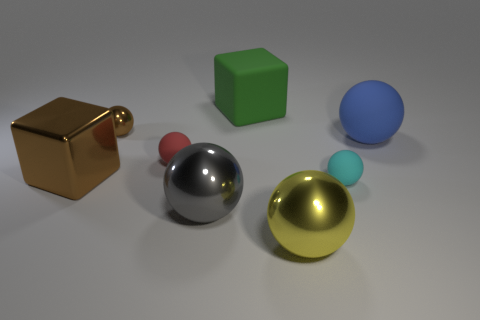Subtract all gray spheres. How many spheres are left? 5 Subtract all small brown metallic spheres. How many spheres are left? 5 Subtract all blue spheres. Subtract all blue cylinders. How many spheres are left? 5 Add 1 big metallic blocks. How many objects exist? 9 Subtract all balls. How many objects are left? 2 Add 7 small cyan rubber objects. How many small cyan rubber objects exist? 8 Subtract 1 brown spheres. How many objects are left? 7 Subtract all cyan rubber objects. Subtract all gray balls. How many objects are left? 6 Add 8 red matte objects. How many red matte objects are left? 9 